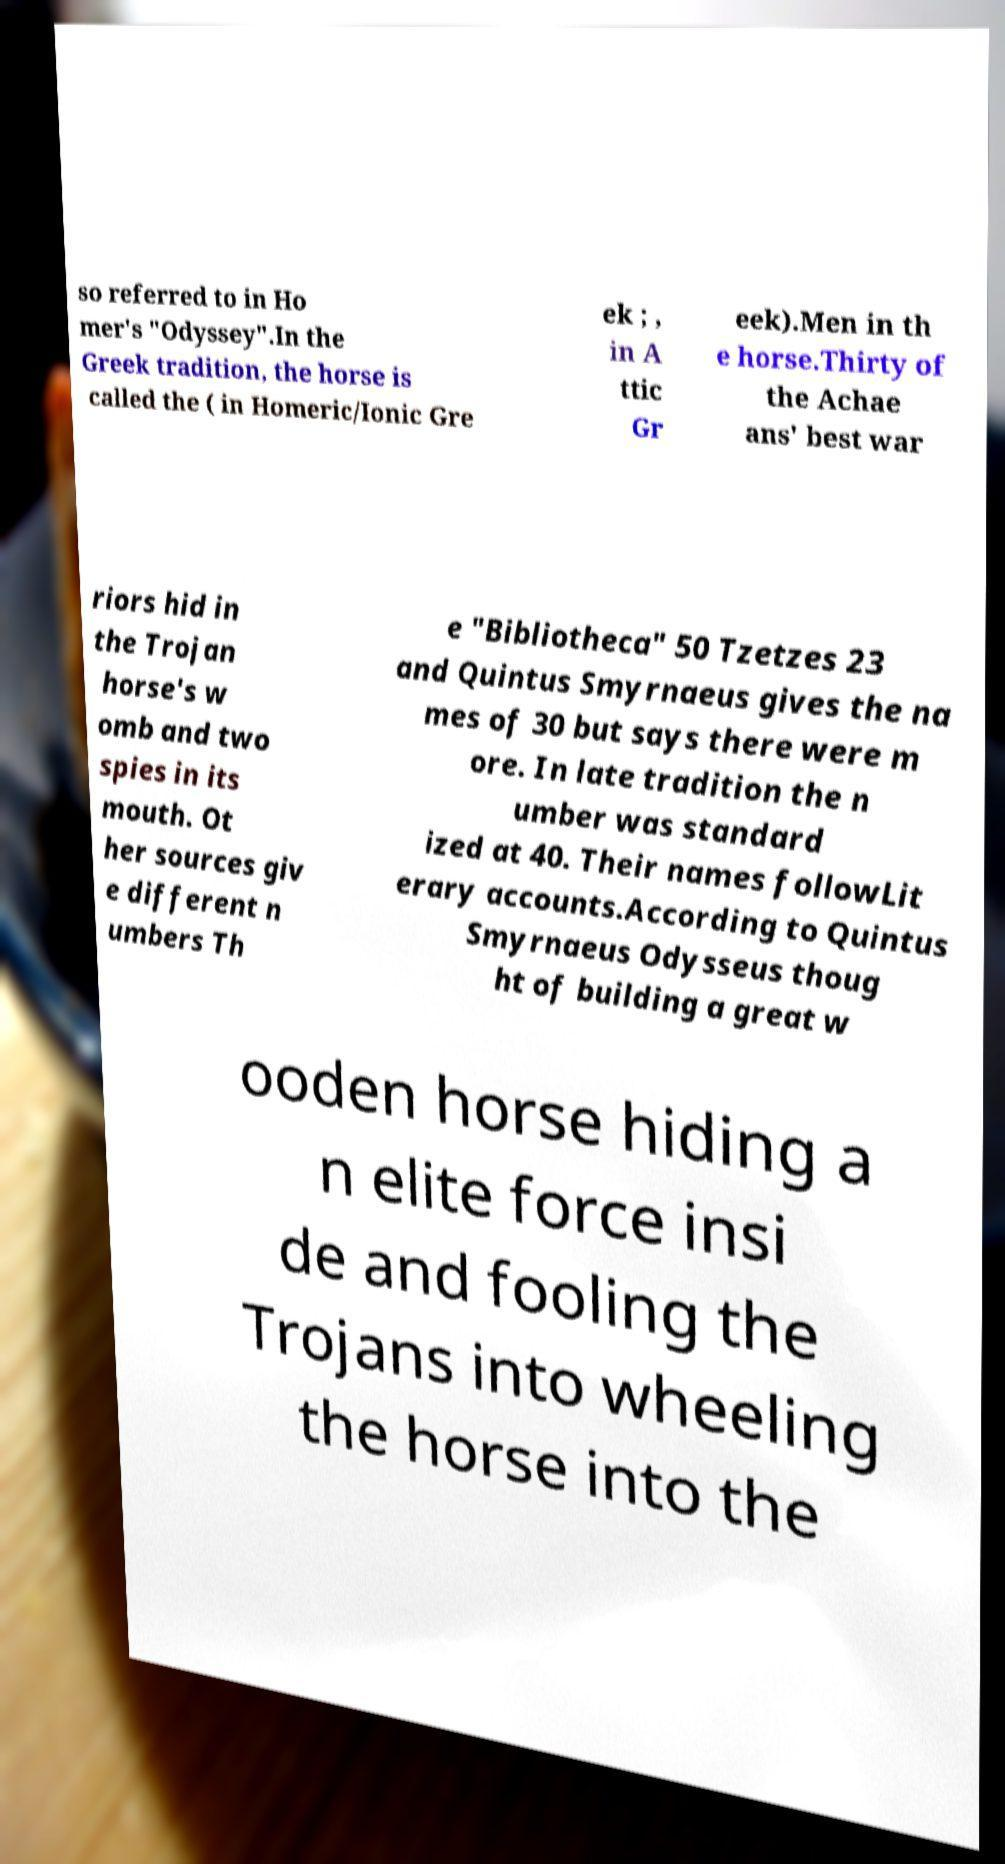There's text embedded in this image that I need extracted. Can you transcribe it verbatim? so referred to in Ho mer's "Odyssey".In the Greek tradition, the horse is called the ( in Homeric/Ionic Gre ek ; , in A ttic Gr eek).Men in th e horse.Thirty of the Achae ans' best war riors hid in the Trojan horse's w omb and two spies in its mouth. Ot her sources giv e different n umbers Th e "Bibliotheca" 50 Tzetzes 23 and Quintus Smyrnaeus gives the na mes of 30 but says there were m ore. In late tradition the n umber was standard ized at 40. Their names followLit erary accounts.According to Quintus Smyrnaeus Odysseus thoug ht of building a great w ooden horse hiding a n elite force insi de and fooling the Trojans into wheeling the horse into the 